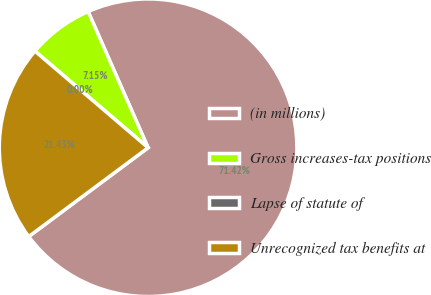Convert chart to OTSL. <chart><loc_0><loc_0><loc_500><loc_500><pie_chart><fcel>(in millions)<fcel>Gross increases-tax positions<fcel>Lapse of statute of<fcel>Unrecognized tax benefits at<nl><fcel>71.42%<fcel>7.15%<fcel>0.0%<fcel>21.43%<nl></chart> 